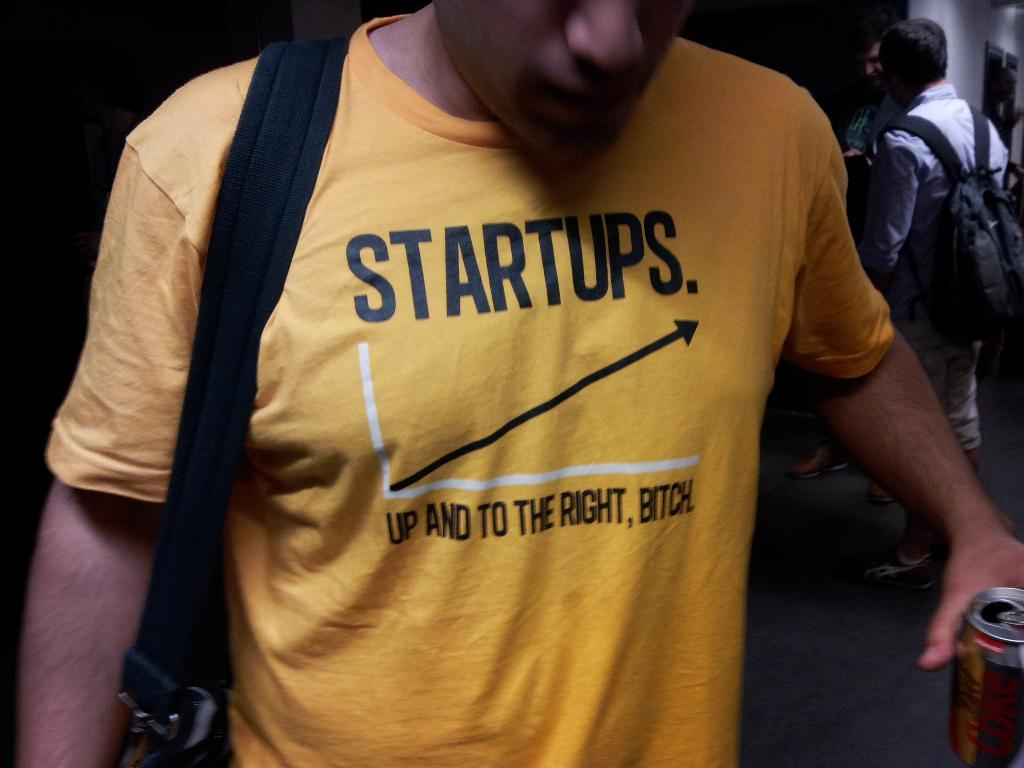Provide a one-sentence caption for the provided image. A man wears a yellow t-shirt with an offensive slogan on it. 